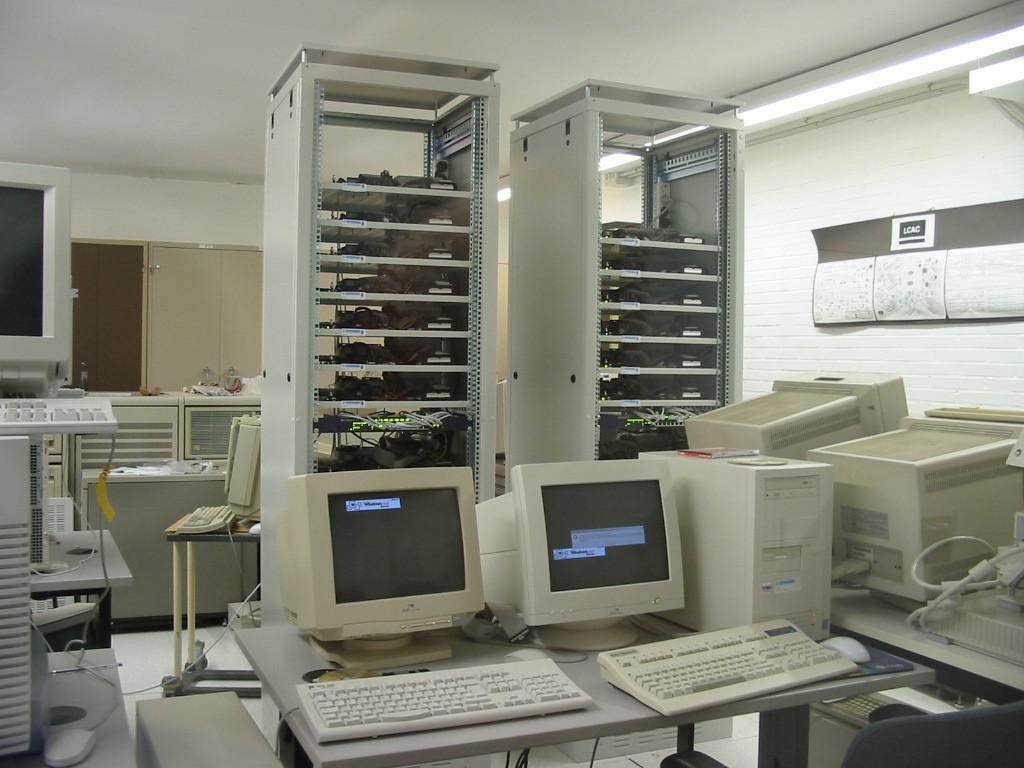What type of space is depicted in the image? There is a room in the image. What can be seen on the table in the room? There are monitors and keyboards on the table in the room. What is present on the racks in the room? There are racks with something on them in the room, but the specific items cannot be determined from the provided facts. What type of storage units are in the room? There are shelves with doors in the room. What is the opinion of the beetle on the shelves in the image? There is no beetle present in the image, so it is not possible to determine its opinion. 